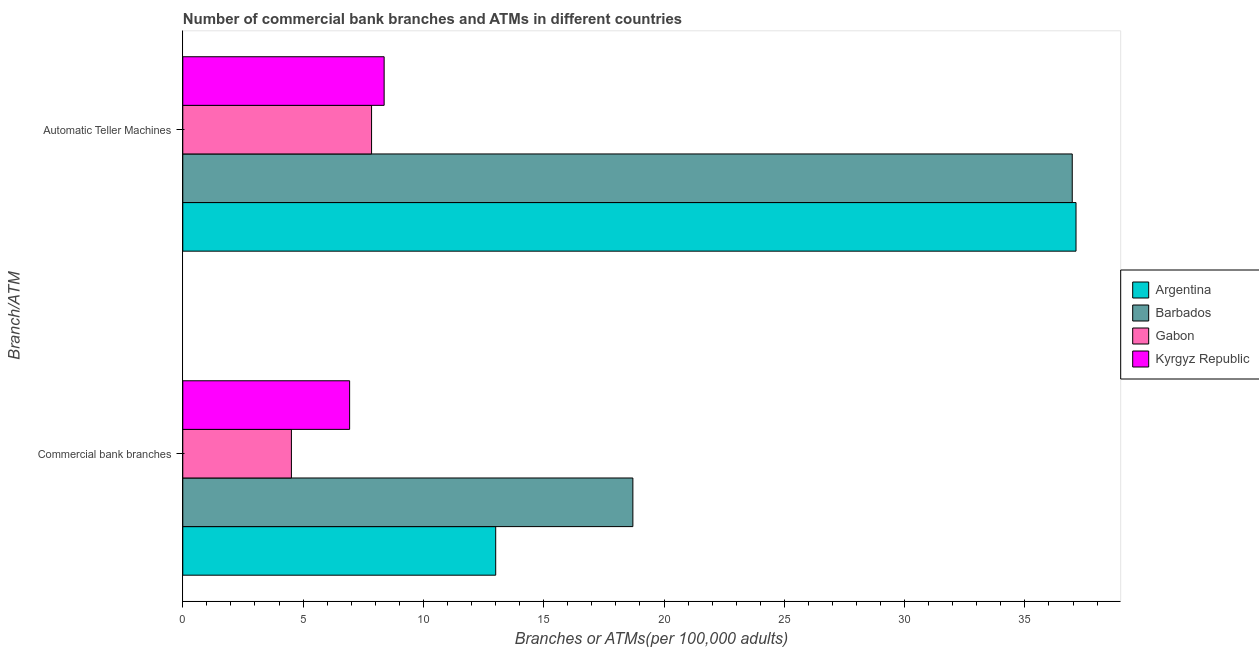How many different coloured bars are there?
Offer a very short reply. 4. How many groups of bars are there?
Provide a succinct answer. 2. Are the number of bars on each tick of the Y-axis equal?
Ensure brevity in your answer.  Yes. What is the label of the 1st group of bars from the top?
Keep it short and to the point. Automatic Teller Machines. What is the number of commercal bank branches in Gabon?
Offer a terse response. 4.51. Across all countries, what is the maximum number of atms?
Offer a terse response. 37.12. Across all countries, what is the minimum number of commercal bank branches?
Keep it short and to the point. 4.51. In which country was the number of atms maximum?
Provide a short and direct response. Argentina. In which country was the number of atms minimum?
Ensure brevity in your answer.  Gabon. What is the total number of commercal bank branches in the graph?
Keep it short and to the point. 43.16. What is the difference between the number of commercal bank branches in Kyrgyz Republic and that in Argentina?
Provide a succinct answer. -6.07. What is the difference between the number of commercal bank branches in Argentina and the number of atms in Barbados?
Make the answer very short. -23.96. What is the average number of atms per country?
Your response must be concise. 22.58. What is the difference between the number of atms and number of commercal bank branches in Argentina?
Your answer should be compact. 24.12. What is the ratio of the number of atms in Gabon to that in Argentina?
Provide a succinct answer. 0.21. Is the number of commercal bank branches in Barbados less than that in Kyrgyz Republic?
Your response must be concise. No. In how many countries, is the number of atms greater than the average number of atms taken over all countries?
Offer a very short reply. 2. What does the 3rd bar from the top in Commercial bank branches represents?
Ensure brevity in your answer.  Barbados. What does the 1st bar from the bottom in Automatic Teller Machines represents?
Your response must be concise. Argentina. Does the graph contain grids?
Make the answer very short. No. What is the title of the graph?
Give a very brief answer. Number of commercial bank branches and ATMs in different countries. What is the label or title of the X-axis?
Your response must be concise. Branches or ATMs(per 100,0 adults). What is the label or title of the Y-axis?
Your response must be concise. Branch/ATM. What is the Branches or ATMs(per 100,000 adults) in Argentina in Commercial bank branches?
Your response must be concise. 13.01. What is the Branches or ATMs(per 100,000 adults) of Barbados in Commercial bank branches?
Make the answer very short. 18.71. What is the Branches or ATMs(per 100,000 adults) in Gabon in Commercial bank branches?
Offer a very short reply. 4.51. What is the Branches or ATMs(per 100,000 adults) of Kyrgyz Republic in Commercial bank branches?
Make the answer very short. 6.93. What is the Branches or ATMs(per 100,000 adults) of Argentina in Automatic Teller Machines?
Give a very brief answer. 37.12. What is the Branches or ATMs(per 100,000 adults) of Barbados in Automatic Teller Machines?
Make the answer very short. 36.97. What is the Branches or ATMs(per 100,000 adults) in Gabon in Automatic Teller Machines?
Your answer should be very brief. 7.85. What is the Branches or ATMs(per 100,000 adults) of Kyrgyz Republic in Automatic Teller Machines?
Provide a succinct answer. 8.37. Across all Branch/ATM, what is the maximum Branches or ATMs(per 100,000 adults) in Argentina?
Your answer should be compact. 37.12. Across all Branch/ATM, what is the maximum Branches or ATMs(per 100,000 adults) of Barbados?
Your response must be concise. 36.97. Across all Branch/ATM, what is the maximum Branches or ATMs(per 100,000 adults) in Gabon?
Your answer should be very brief. 7.85. Across all Branch/ATM, what is the maximum Branches or ATMs(per 100,000 adults) of Kyrgyz Republic?
Provide a short and direct response. 8.37. Across all Branch/ATM, what is the minimum Branches or ATMs(per 100,000 adults) in Argentina?
Offer a very short reply. 13.01. Across all Branch/ATM, what is the minimum Branches or ATMs(per 100,000 adults) of Barbados?
Offer a terse response. 18.71. Across all Branch/ATM, what is the minimum Branches or ATMs(per 100,000 adults) in Gabon?
Your response must be concise. 4.51. Across all Branch/ATM, what is the minimum Branches or ATMs(per 100,000 adults) of Kyrgyz Republic?
Make the answer very short. 6.93. What is the total Branches or ATMs(per 100,000 adults) of Argentina in the graph?
Offer a terse response. 50.13. What is the total Branches or ATMs(per 100,000 adults) in Barbados in the graph?
Give a very brief answer. 55.67. What is the total Branches or ATMs(per 100,000 adults) in Gabon in the graph?
Provide a short and direct response. 12.36. What is the total Branches or ATMs(per 100,000 adults) in Kyrgyz Republic in the graph?
Your answer should be very brief. 15.3. What is the difference between the Branches or ATMs(per 100,000 adults) in Argentina in Commercial bank branches and that in Automatic Teller Machines?
Provide a succinct answer. -24.12. What is the difference between the Branches or ATMs(per 100,000 adults) in Barbados in Commercial bank branches and that in Automatic Teller Machines?
Make the answer very short. -18.26. What is the difference between the Branches or ATMs(per 100,000 adults) of Gabon in Commercial bank branches and that in Automatic Teller Machines?
Provide a succinct answer. -3.33. What is the difference between the Branches or ATMs(per 100,000 adults) in Kyrgyz Republic in Commercial bank branches and that in Automatic Teller Machines?
Your response must be concise. -1.43. What is the difference between the Branches or ATMs(per 100,000 adults) of Argentina in Commercial bank branches and the Branches or ATMs(per 100,000 adults) of Barbados in Automatic Teller Machines?
Offer a very short reply. -23.96. What is the difference between the Branches or ATMs(per 100,000 adults) in Argentina in Commercial bank branches and the Branches or ATMs(per 100,000 adults) in Gabon in Automatic Teller Machines?
Your response must be concise. 5.16. What is the difference between the Branches or ATMs(per 100,000 adults) in Argentina in Commercial bank branches and the Branches or ATMs(per 100,000 adults) in Kyrgyz Republic in Automatic Teller Machines?
Make the answer very short. 4.64. What is the difference between the Branches or ATMs(per 100,000 adults) of Barbados in Commercial bank branches and the Branches or ATMs(per 100,000 adults) of Gabon in Automatic Teller Machines?
Make the answer very short. 10.86. What is the difference between the Branches or ATMs(per 100,000 adults) of Barbados in Commercial bank branches and the Branches or ATMs(per 100,000 adults) of Kyrgyz Republic in Automatic Teller Machines?
Your answer should be compact. 10.34. What is the difference between the Branches or ATMs(per 100,000 adults) of Gabon in Commercial bank branches and the Branches or ATMs(per 100,000 adults) of Kyrgyz Republic in Automatic Teller Machines?
Ensure brevity in your answer.  -3.85. What is the average Branches or ATMs(per 100,000 adults) of Argentina per Branch/ATM?
Your response must be concise. 25.07. What is the average Branches or ATMs(per 100,000 adults) of Barbados per Branch/ATM?
Keep it short and to the point. 27.84. What is the average Branches or ATMs(per 100,000 adults) of Gabon per Branch/ATM?
Make the answer very short. 6.18. What is the average Branches or ATMs(per 100,000 adults) in Kyrgyz Republic per Branch/ATM?
Your answer should be very brief. 7.65. What is the difference between the Branches or ATMs(per 100,000 adults) of Argentina and Branches or ATMs(per 100,000 adults) of Barbados in Commercial bank branches?
Give a very brief answer. -5.7. What is the difference between the Branches or ATMs(per 100,000 adults) in Argentina and Branches or ATMs(per 100,000 adults) in Gabon in Commercial bank branches?
Offer a terse response. 8.49. What is the difference between the Branches or ATMs(per 100,000 adults) of Argentina and Branches or ATMs(per 100,000 adults) of Kyrgyz Republic in Commercial bank branches?
Your response must be concise. 6.07. What is the difference between the Branches or ATMs(per 100,000 adults) in Barbados and Branches or ATMs(per 100,000 adults) in Gabon in Commercial bank branches?
Your answer should be compact. 14.19. What is the difference between the Branches or ATMs(per 100,000 adults) in Barbados and Branches or ATMs(per 100,000 adults) in Kyrgyz Republic in Commercial bank branches?
Make the answer very short. 11.77. What is the difference between the Branches or ATMs(per 100,000 adults) of Gabon and Branches or ATMs(per 100,000 adults) of Kyrgyz Republic in Commercial bank branches?
Provide a succinct answer. -2.42. What is the difference between the Branches or ATMs(per 100,000 adults) in Argentina and Branches or ATMs(per 100,000 adults) in Barbados in Automatic Teller Machines?
Offer a terse response. 0.16. What is the difference between the Branches or ATMs(per 100,000 adults) of Argentina and Branches or ATMs(per 100,000 adults) of Gabon in Automatic Teller Machines?
Provide a succinct answer. 29.28. What is the difference between the Branches or ATMs(per 100,000 adults) of Argentina and Branches or ATMs(per 100,000 adults) of Kyrgyz Republic in Automatic Teller Machines?
Provide a succinct answer. 28.76. What is the difference between the Branches or ATMs(per 100,000 adults) of Barbados and Branches or ATMs(per 100,000 adults) of Gabon in Automatic Teller Machines?
Your response must be concise. 29.12. What is the difference between the Branches or ATMs(per 100,000 adults) in Barbados and Branches or ATMs(per 100,000 adults) in Kyrgyz Republic in Automatic Teller Machines?
Give a very brief answer. 28.6. What is the difference between the Branches or ATMs(per 100,000 adults) of Gabon and Branches or ATMs(per 100,000 adults) of Kyrgyz Republic in Automatic Teller Machines?
Offer a very short reply. -0.52. What is the ratio of the Branches or ATMs(per 100,000 adults) in Argentina in Commercial bank branches to that in Automatic Teller Machines?
Provide a short and direct response. 0.35. What is the ratio of the Branches or ATMs(per 100,000 adults) in Barbados in Commercial bank branches to that in Automatic Teller Machines?
Offer a very short reply. 0.51. What is the ratio of the Branches or ATMs(per 100,000 adults) of Gabon in Commercial bank branches to that in Automatic Teller Machines?
Provide a short and direct response. 0.58. What is the ratio of the Branches or ATMs(per 100,000 adults) of Kyrgyz Republic in Commercial bank branches to that in Automatic Teller Machines?
Ensure brevity in your answer.  0.83. What is the difference between the highest and the second highest Branches or ATMs(per 100,000 adults) in Argentina?
Make the answer very short. 24.12. What is the difference between the highest and the second highest Branches or ATMs(per 100,000 adults) of Barbados?
Give a very brief answer. 18.26. What is the difference between the highest and the second highest Branches or ATMs(per 100,000 adults) in Gabon?
Offer a very short reply. 3.33. What is the difference between the highest and the second highest Branches or ATMs(per 100,000 adults) in Kyrgyz Republic?
Your response must be concise. 1.43. What is the difference between the highest and the lowest Branches or ATMs(per 100,000 adults) in Argentina?
Provide a succinct answer. 24.12. What is the difference between the highest and the lowest Branches or ATMs(per 100,000 adults) of Barbados?
Provide a succinct answer. 18.26. What is the difference between the highest and the lowest Branches or ATMs(per 100,000 adults) in Gabon?
Keep it short and to the point. 3.33. What is the difference between the highest and the lowest Branches or ATMs(per 100,000 adults) of Kyrgyz Republic?
Offer a very short reply. 1.43. 